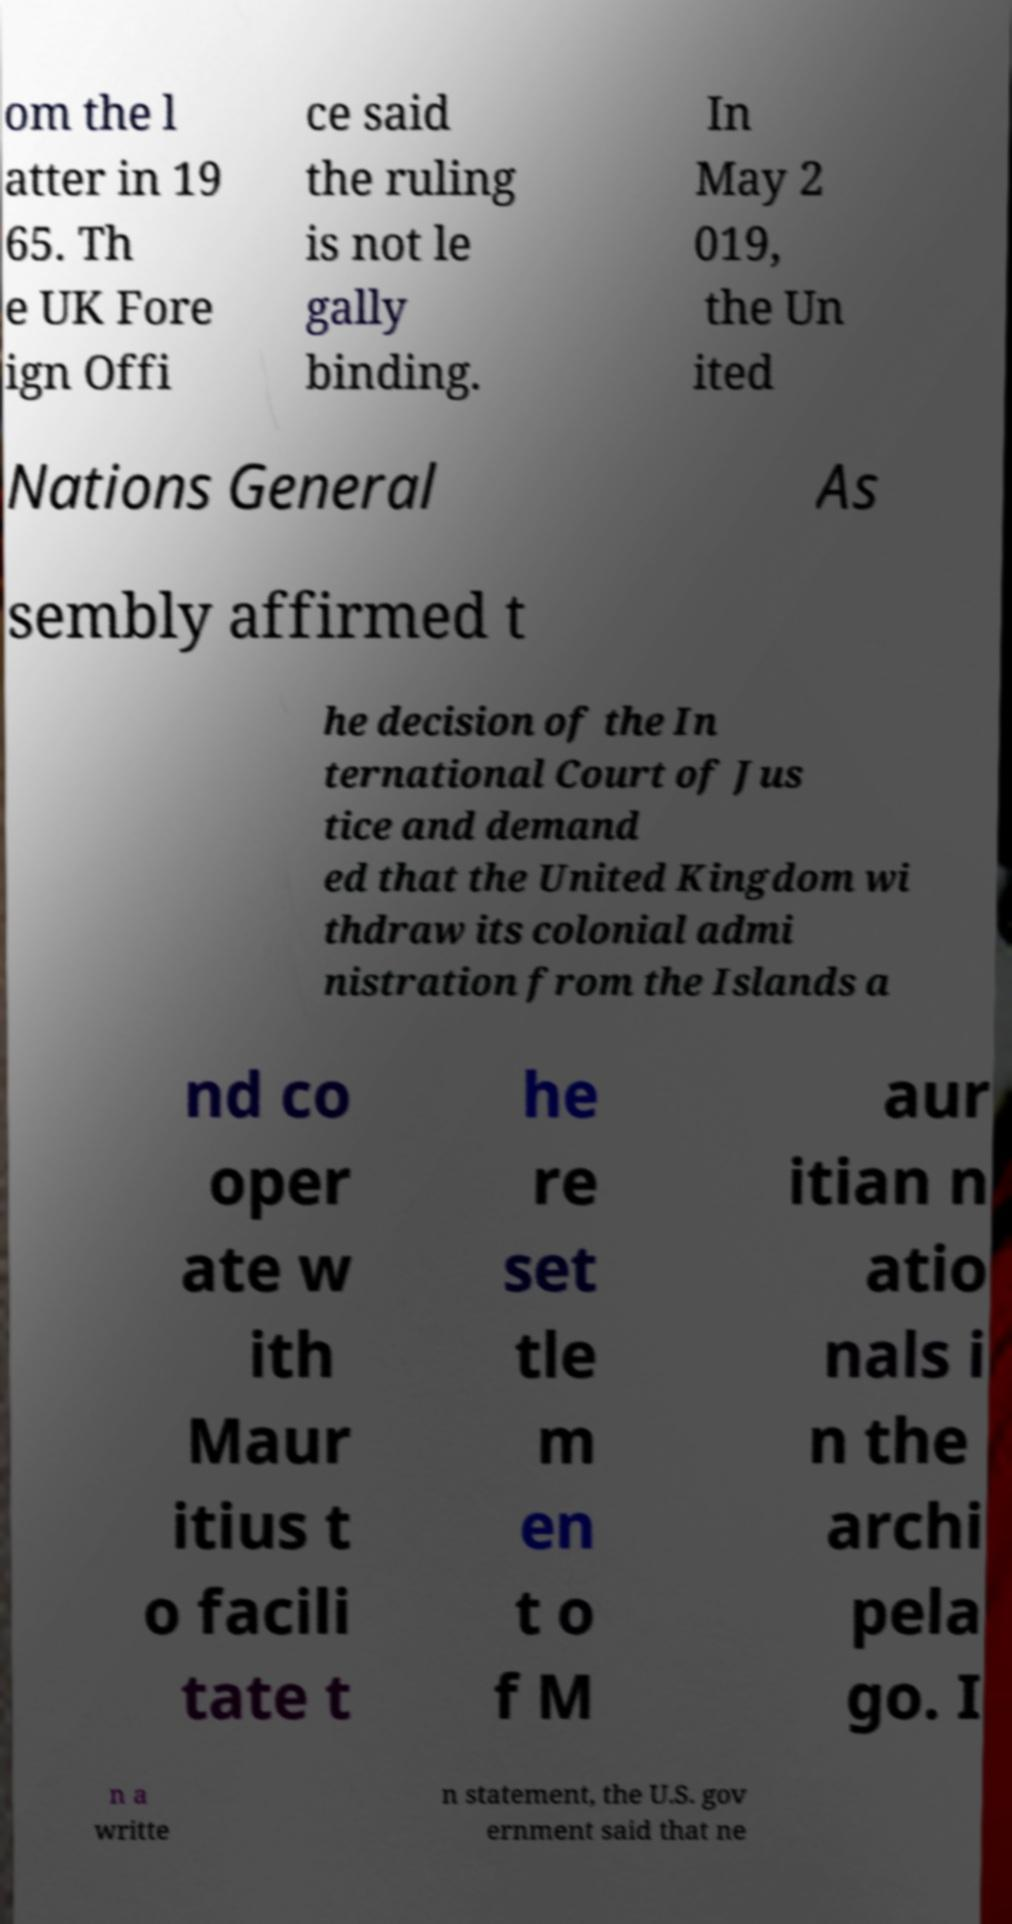Please read and relay the text visible in this image. What does it say? om the l atter in 19 65. Th e UK Fore ign Offi ce said the ruling is not le gally binding. In May 2 019, the Un ited Nations General As sembly affirmed t he decision of the In ternational Court of Jus tice and demand ed that the United Kingdom wi thdraw its colonial admi nistration from the Islands a nd co oper ate w ith Maur itius t o facili tate t he re set tle m en t o f M aur itian n atio nals i n the archi pela go. I n a writte n statement, the U.S. gov ernment said that ne 